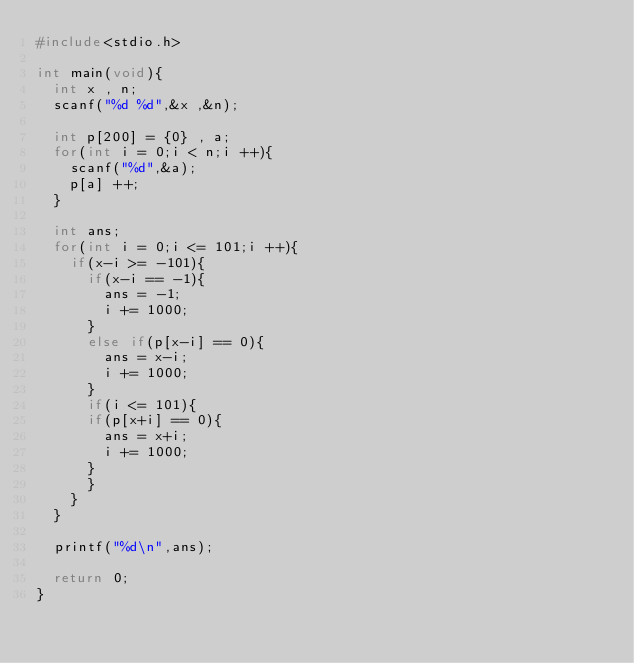Convert code to text. <code><loc_0><loc_0><loc_500><loc_500><_C_>#include<stdio.h>

int main(void){
  int x , n;
  scanf("%d %d",&x ,&n);

  int p[200] = {0} , a;
  for(int i = 0;i < n;i ++){
    scanf("%d",&a);
    p[a] ++;
  }

  int ans;
  for(int i = 0;i <= 101;i ++){
    if(x-i >= -101){
      if(x-i == -1){
        ans = -1;
        i += 1000;
      }
      else if(p[x-i] == 0){
        ans = x-i;
        i += 1000;
      }
      if(i <= 101){
      if(p[x+i] == 0){
        ans = x+i;
        i += 1000;
      }
      }
    }
  }

  printf("%d\n",ans);

  return 0;
}</code> 